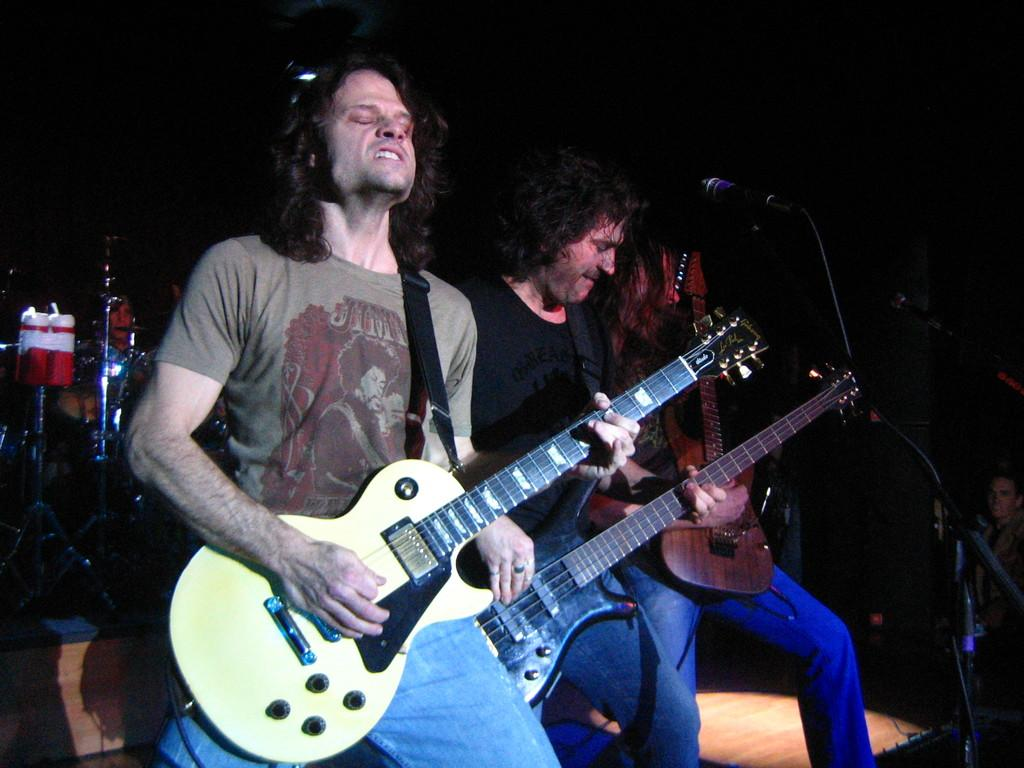How many people are in the image? There are three men in the image. What are the men doing in the image? The men are standing and holding guitars. What object is present in the image that is typically used for amplifying sound? There is a microphone in the image. What can be observed about the lighting in the image? The background of the image is dark. What type of sweater is the man in the middle wearing in the image? There is no sweater visible in the image; the men are wearing shirts and holding guitars. What educational institution is associated with the men in the image? There is no information about any educational institution in the image; it only shows three men holding guitars and standing near a microphone. 